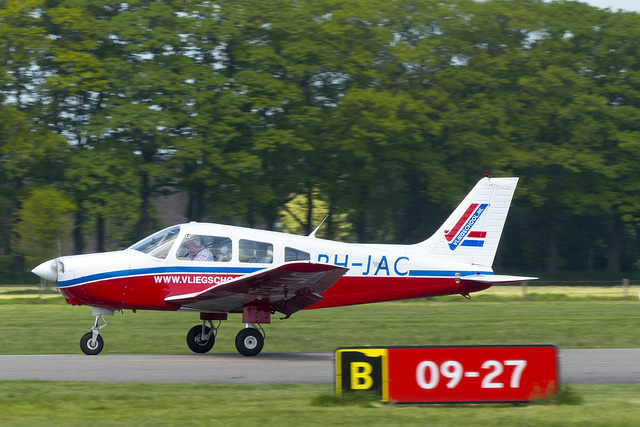Please identify all text content in this image. 09- B 27 - J A C VLSCSCHOOL WWW.VLIEGSCN 